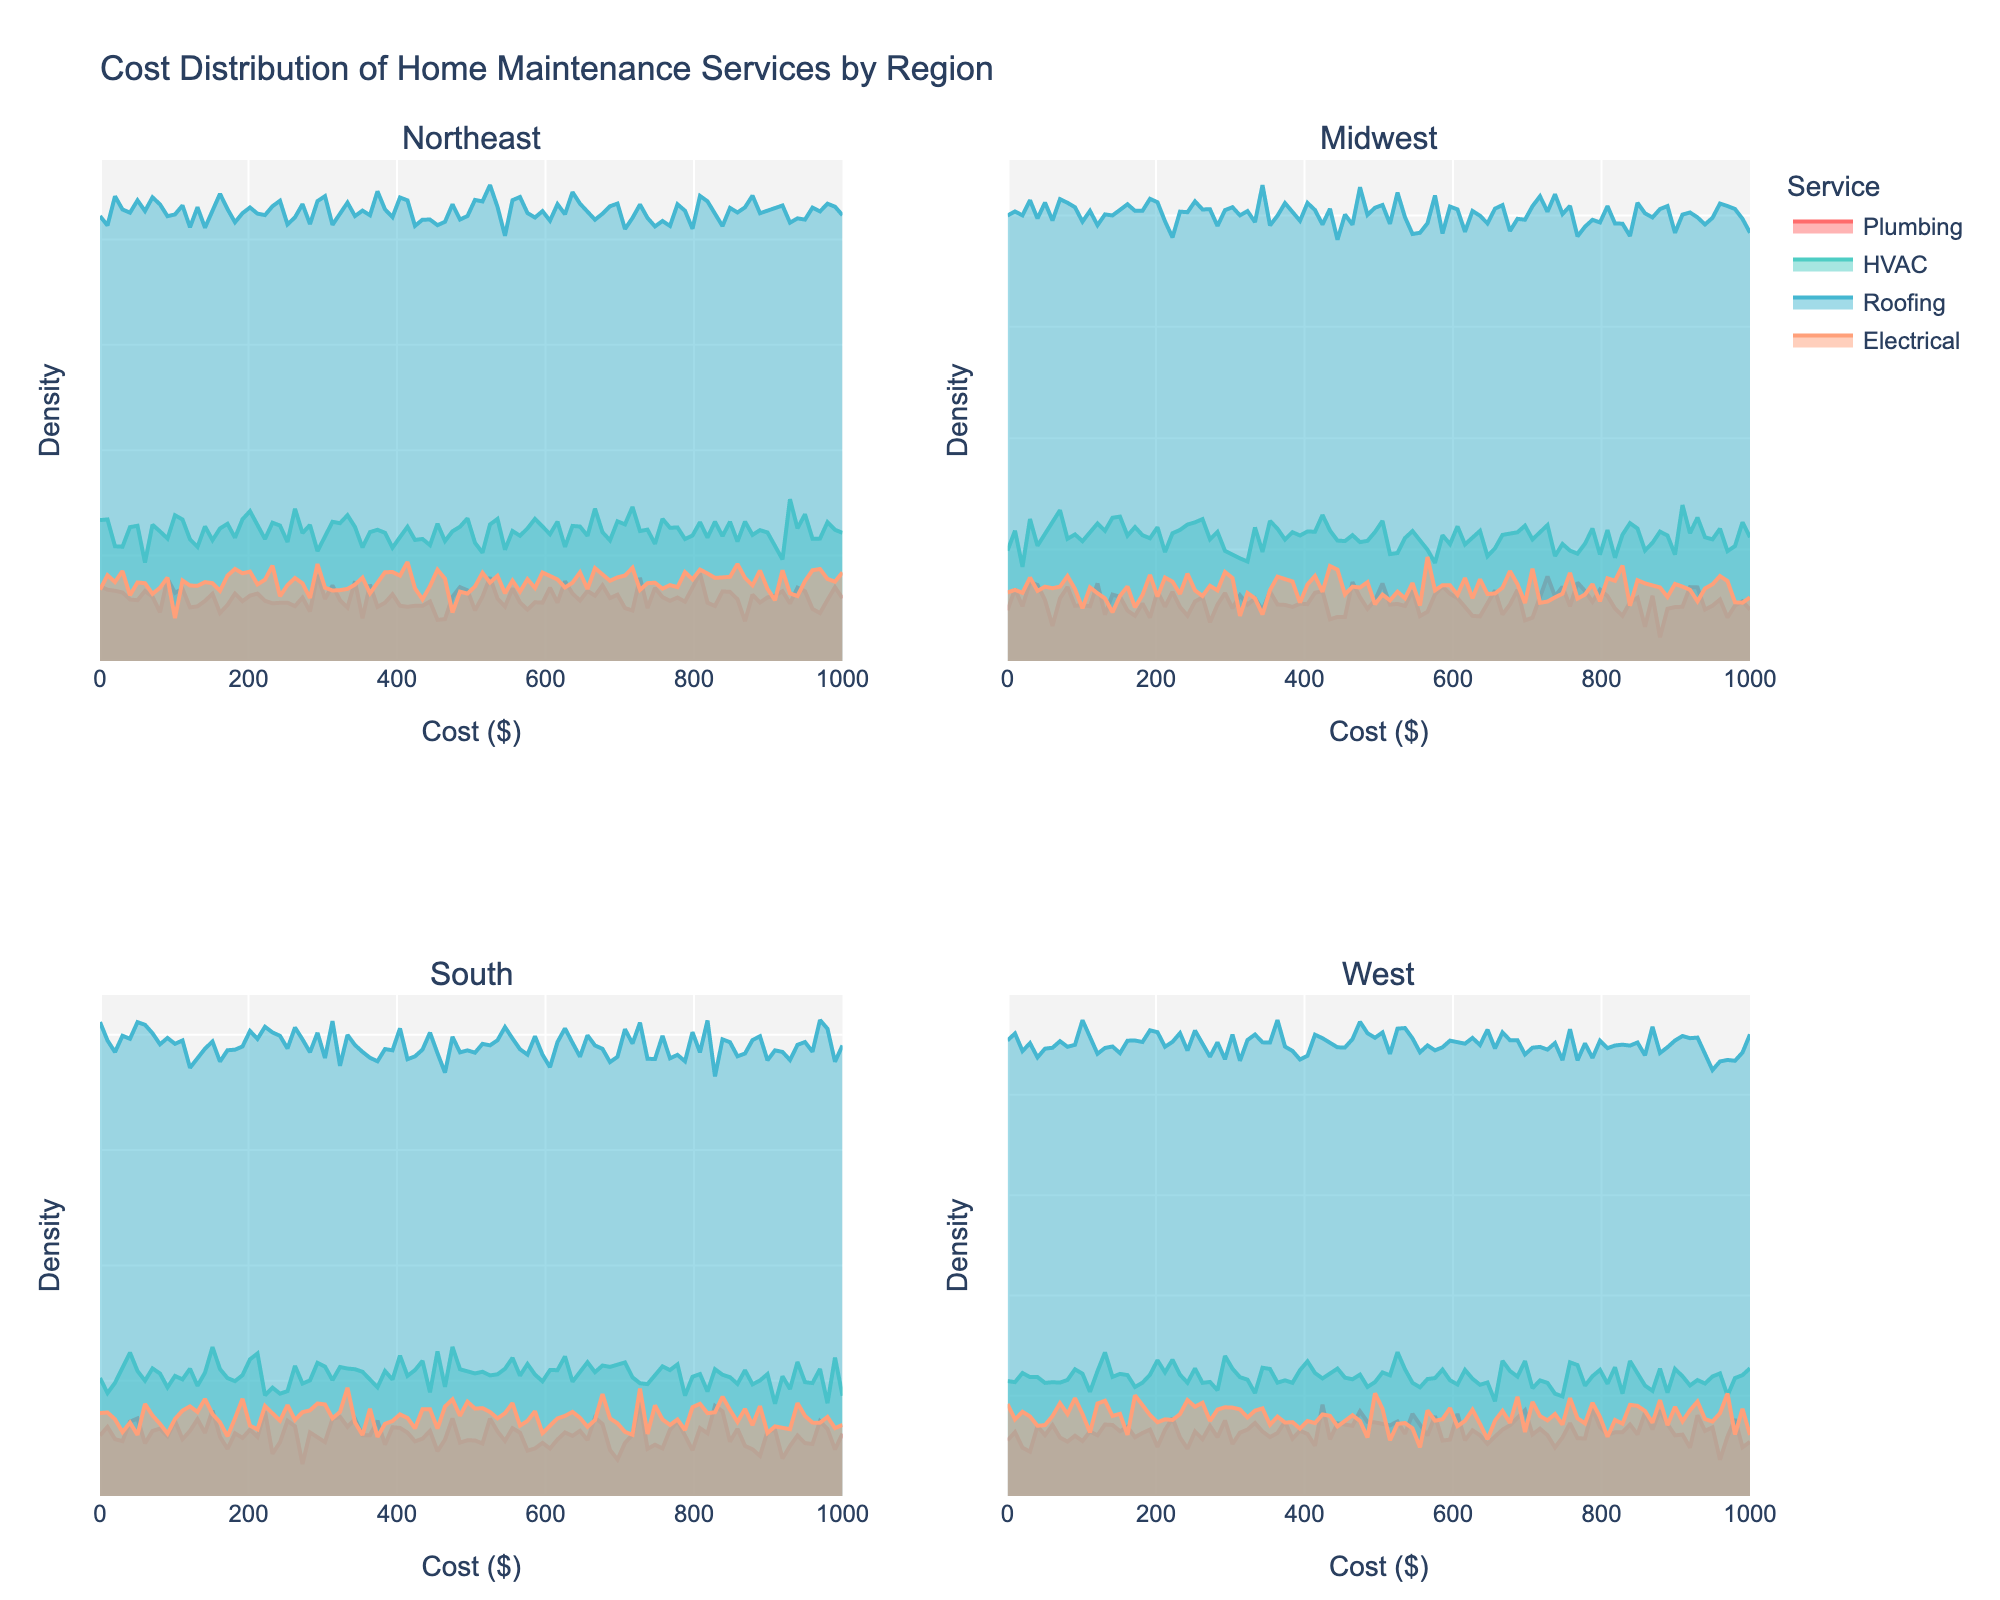What is the title of the figure? The title of the figure is usually displayed at the top center of the plot. In this figure, it is labeled as "Cost Distribution of Home Maintenance Services by Region."
Answer: Cost Distribution of Home Maintenance Services by Region What do the x-axes in each subplot represent? The x-axes in each subplot represent the cost distribution in dollars ($) for the home maintenance services. This can be inferred from the labels on the x-axes.
Answer: Cost ($) How many subplots are there in the figure? By count, there are four distinct subplots in the figure representing different geographic regions (Northeast, Midwest, South, West). Each subplot has its respective title.
Answer: Four Which service has the highest cost in the Midwest region? In the Midwest subplot, observe the density plots for each service. The density plot that extends farthest to the right represents the highest cost, which is Roofing.
Answer: Roofing Are the costs of the Electrical services higher in the Northeast or the South region? Compare the Electrical services' density plots in the Northeast and South subplots. The one with the density plot extending further to the right has higher costs. In this case, the Electrical service cost is higher in the Northeast region.
Answer: Northeast What is the color used for the Plumbing service in the plots? The colors for each service are consistent across subplots. By identifying the color used in any one subplot, you can determine the color for Plumbing services, which is red.
Answer: Red How does the average cost of HVAC services in the Northeast compare to that in the West? Look at the density plots for HVAC services in both the Northeast and West subplots. The average cost can be inferred from the peak of the density curve. The average cost is slightly higher in the Northeast compared to the West.
Answer: Northeast Between which cost values do the majority of Roofing service costs lie in the South region? Observe the peaks and spread of the density plot for Roofing services in the South subplot. Most of the density (peak area) lies between 750 and 800 dollars.
Answer: 750-800 dollars Is the distribution of Plumbing service costs more spread out in the Midwest or West? Compare the spread of the density plots for Plumbing services in the Midwest and West subplots. The West's density plot has a wider spread, indicating more varied costs.
Answer: West 